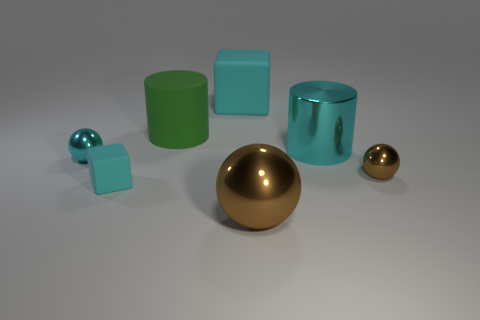What shape is the large cyan thing that is made of the same material as the small brown ball? The large cyan object sharing the same glossy material as the small brown ball is a cylinder. 